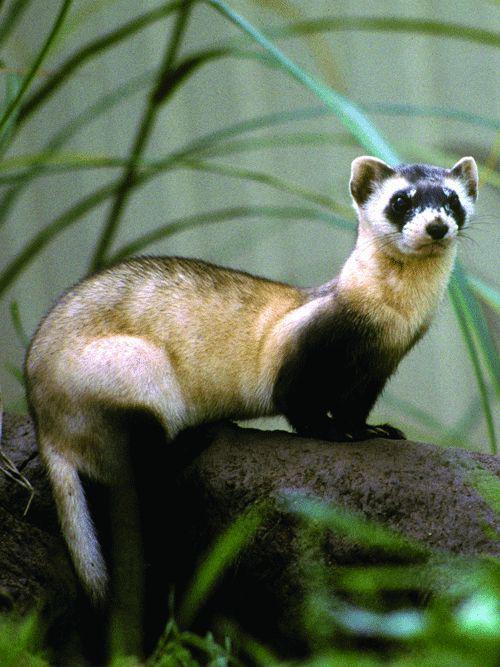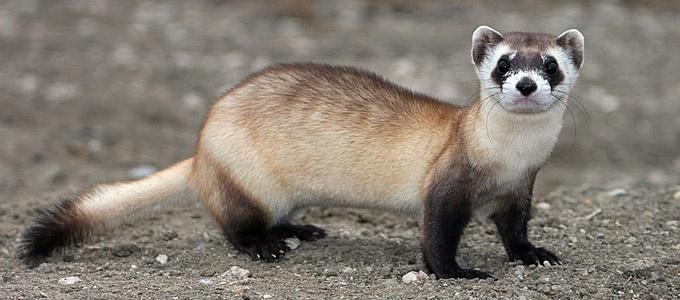The first image is the image on the left, the second image is the image on the right. Examine the images to the left and right. Is the description "there are two ferrets standing on sandy dirt in the image pair" accurate? Answer yes or no. No. The first image is the image on the left, the second image is the image on the right. Assess this claim about the two images: "One image shows a single ferret with all its feet off the ground and its face forward.". Correct or not? Answer yes or no. No. 